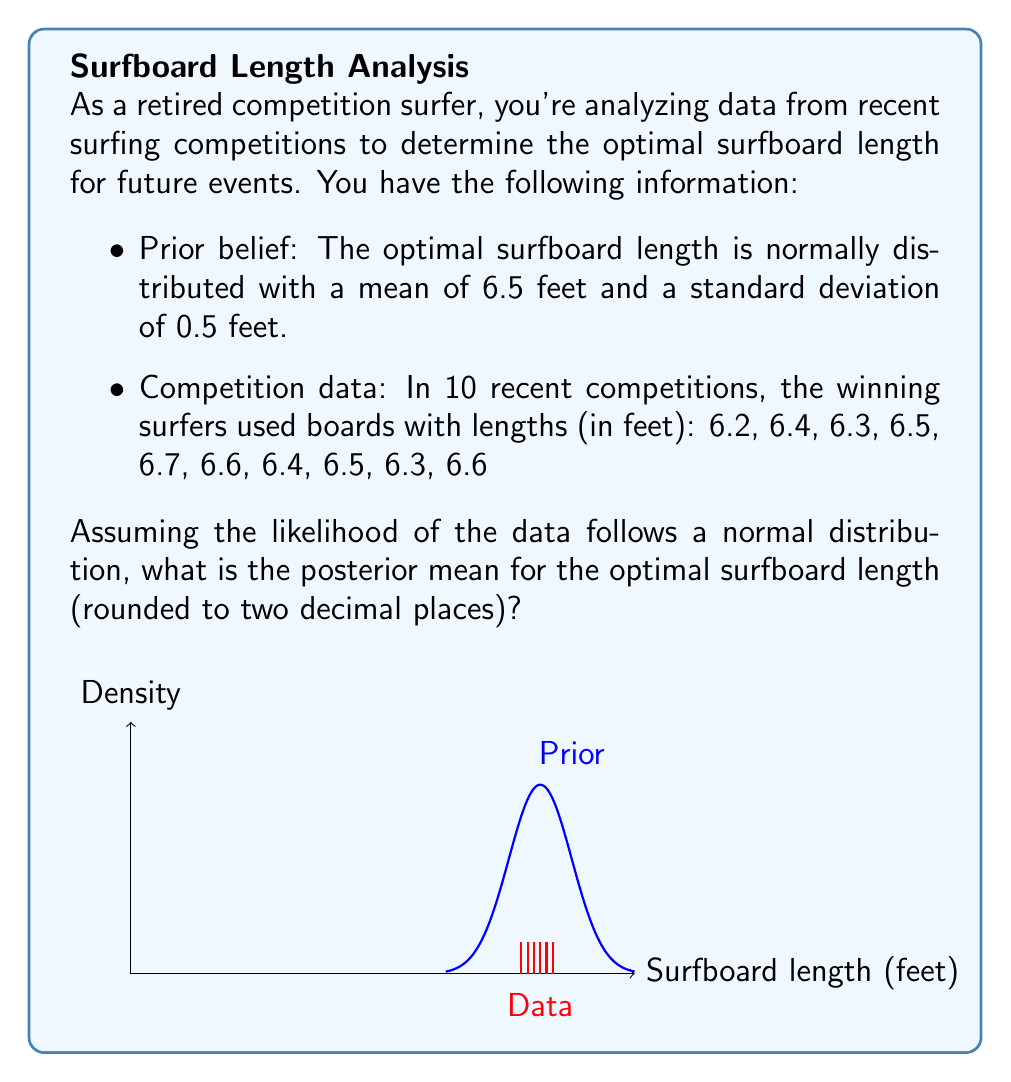Help me with this question. Let's approach this using Bayesian inference:

1) Prior distribution: $\mu_0 = 6.5$, $\sigma_0 = 0.5$

2) Data: $n = 10$ observations, sample mean $\bar{x} = 6.45$

3) For the likelihood, we need to calculate the sample variance:
   $$s^2 = \frac{1}{n-1}\sum_{i=1}^n (x_i - \bar{x})^2 = 0.0272$$
   So, $s = \sqrt{0.0272} = 0.165$

4) The posterior distribution for the mean with a normal prior and normal likelihood is also normal, with parameters:

   $$\mu_n = \frac{\frac{\mu_0}{\sigma_0^2} + \frac{n\bar{x}}{s^2}}{\frac{1}{\sigma_0^2} + \frac{n}{s^2}}$$

   $$\frac{1}{\sigma_n^2} = \frac{1}{\sigma_0^2} + \frac{n}{s^2}$$

5) Let's calculate:
   $$\frac{1}{\sigma_n^2} = \frac{1}{0.5^2} + \frac{10}{0.165^2} = 4 + 367.35 = 371.35$$
   $$\sigma_n^2 = \frac{1}{371.35} = 0.002692$$

6) Now for $\mu_n$:
   $$\mu_n = \frac{\frac{6.5}{0.5^2} + \frac{10 * 6.45}{0.165^2}}{371.35} = \frac{26 + 2368.69}{371.35} = 6.45$$

Therefore, the posterior mean for the optimal surfboard length is 6.45 feet.
Answer: 6.45 feet 